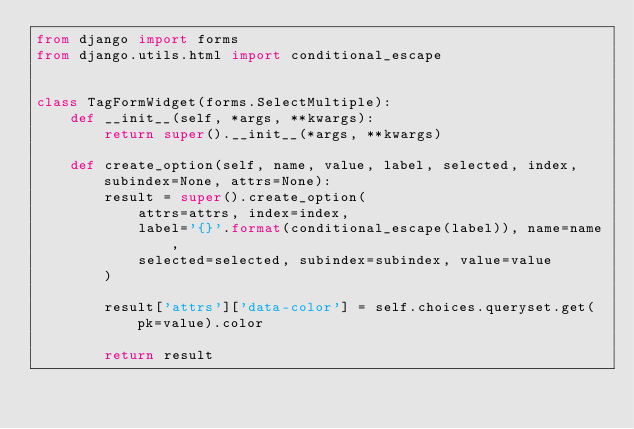<code> <loc_0><loc_0><loc_500><loc_500><_Python_>from django import forms
from django.utils.html import conditional_escape


class TagFormWidget(forms.SelectMultiple):
    def __init__(self, *args, **kwargs):
        return super().__init__(*args, **kwargs)

    def create_option(self, name, value, label, selected, index, subindex=None, attrs=None):
        result = super().create_option(
            attrs=attrs, index=index,
            label='{}'.format(conditional_escape(label)), name=name,
            selected=selected, subindex=subindex, value=value
        )

        result['attrs']['data-color'] = self.choices.queryset.get(pk=value).color

        return result
</code> 